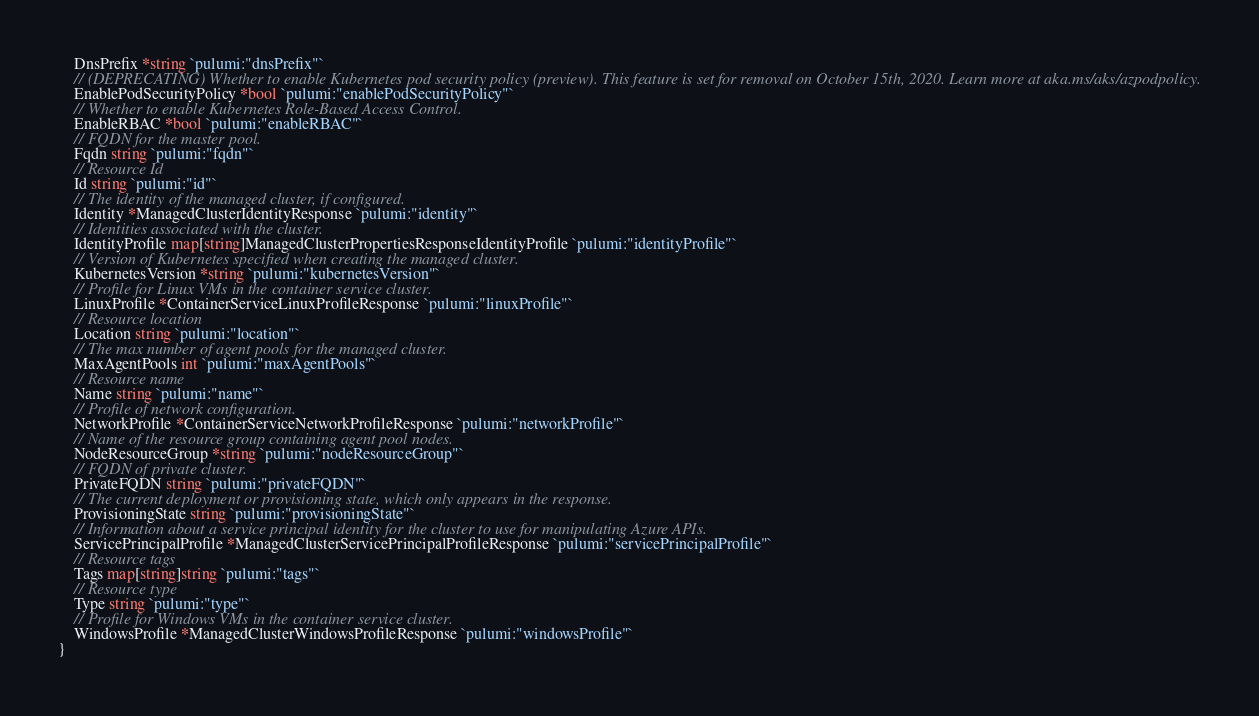<code> <loc_0><loc_0><loc_500><loc_500><_Go_>	DnsPrefix *string `pulumi:"dnsPrefix"`
	// (DEPRECATING) Whether to enable Kubernetes pod security policy (preview). This feature is set for removal on October 15th, 2020. Learn more at aka.ms/aks/azpodpolicy.
	EnablePodSecurityPolicy *bool `pulumi:"enablePodSecurityPolicy"`
	// Whether to enable Kubernetes Role-Based Access Control.
	EnableRBAC *bool `pulumi:"enableRBAC"`
	// FQDN for the master pool.
	Fqdn string `pulumi:"fqdn"`
	// Resource Id
	Id string `pulumi:"id"`
	// The identity of the managed cluster, if configured.
	Identity *ManagedClusterIdentityResponse `pulumi:"identity"`
	// Identities associated with the cluster.
	IdentityProfile map[string]ManagedClusterPropertiesResponseIdentityProfile `pulumi:"identityProfile"`
	// Version of Kubernetes specified when creating the managed cluster.
	KubernetesVersion *string `pulumi:"kubernetesVersion"`
	// Profile for Linux VMs in the container service cluster.
	LinuxProfile *ContainerServiceLinuxProfileResponse `pulumi:"linuxProfile"`
	// Resource location
	Location string `pulumi:"location"`
	// The max number of agent pools for the managed cluster.
	MaxAgentPools int `pulumi:"maxAgentPools"`
	// Resource name
	Name string `pulumi:"name"`
	// Profile of network configuration.
	NetworkProfile *ContainerServiceNetworkProfileResponse `pulumi:"networkProfile"`
	// Name of the resource group containing agent pool nodes.
	NodeResourceGroup *string `pulumi:"nodeResourceGroup"`
	// FQDN of private cluster.
	PrivateFQDN string `pulumi:"privateFQDN"`
	// The current deployment or provisioning state, which only appears in the response.
	ProvisioningState string `pulumi:"provisioningState"`
	// Information about a service principal identity for the cluster to use for manipulating Azure APIs.
	ServicePrincipalProfile *ManagedClusterServicePrincipalProfileResponse `pulumi:"servicePrincipalProfile"`
	// Resource tags
	Tags map[string]string `pulumi:"tags"`
	// Resource type
	Type string `pulumi:"type"`
	// Profile for Windows VMs in the container service cluster.
	WindowsProfile *ManagedClusterWindowsProfileResponse `pulumi:"windowsProfile"`
}
</code> 